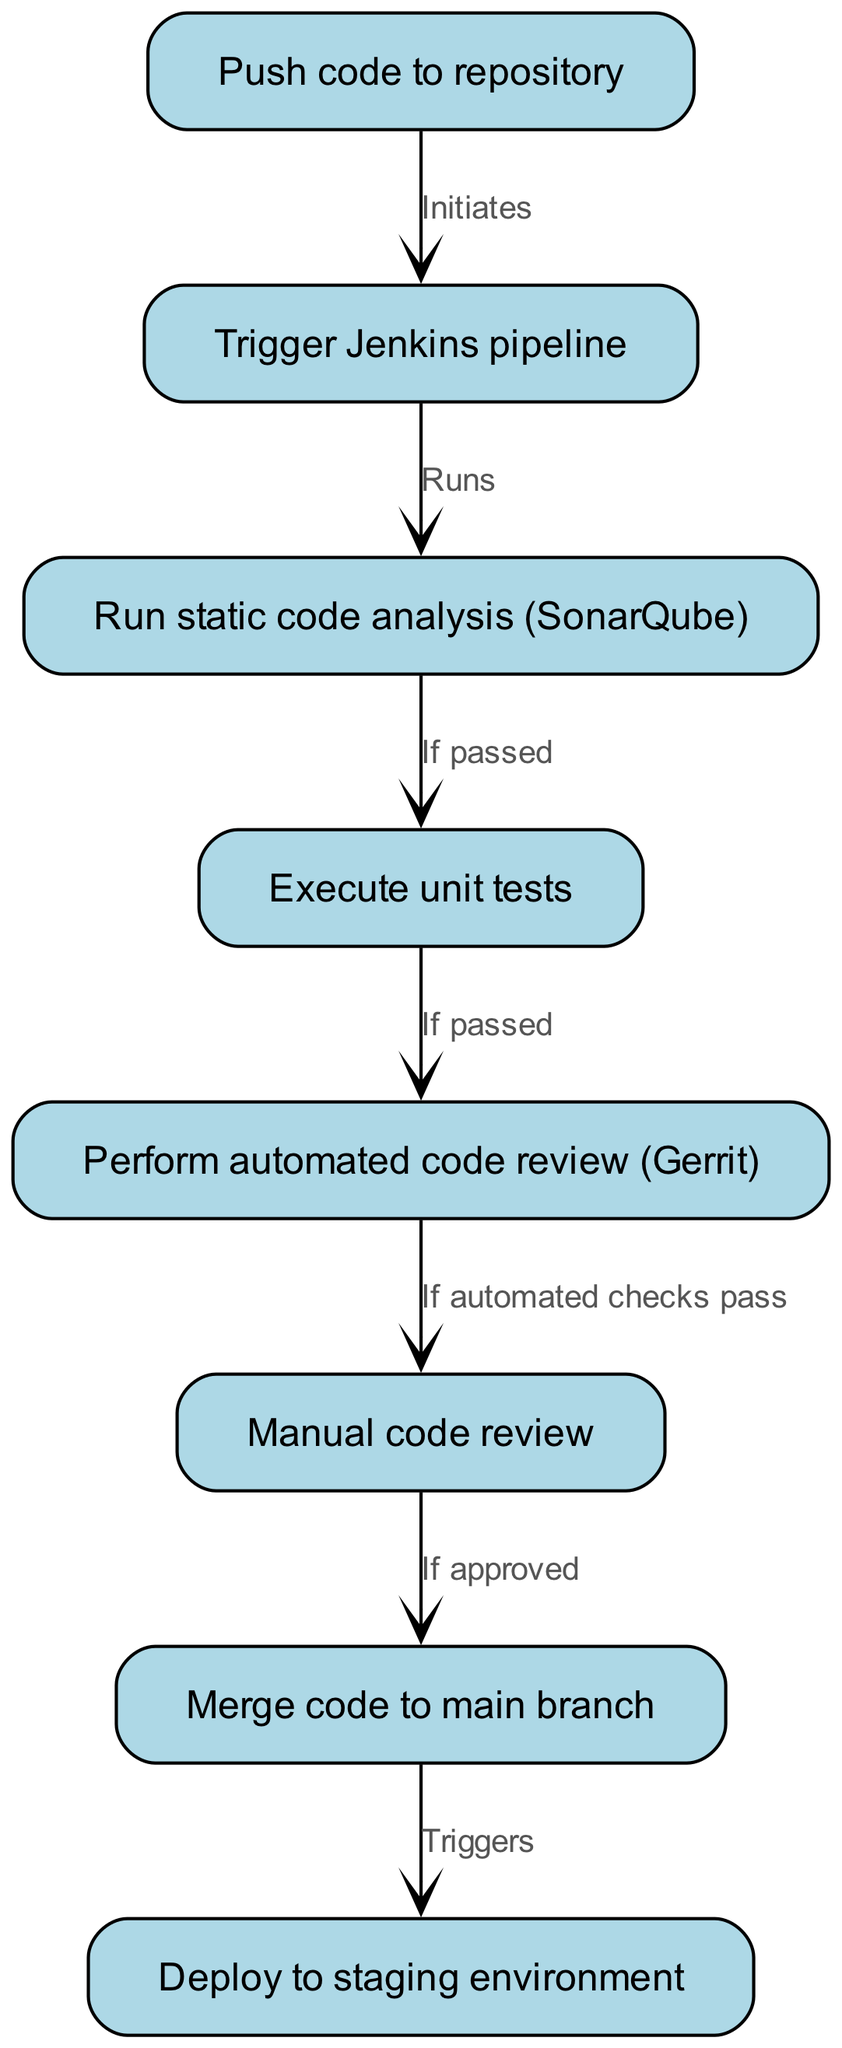What is the first step in the process flow? The first step is labeled as "Push code to repository" as indicated at the beginning of the flowchart. It is the starting point for the automated code review and integration process.
Answer: Push code to repository How many nodes are present in the diagram? The diagram contains eight nodes, each representing a specific step in the automated code review and integration process.
Answer: Eight What action triggers the Jenkins pipeline? The Jenkins pipeline is triggered by the action of pushing code to the repository, represented as the first step in the flow.
Answer: Push code to repository What step follows after the automated code review? The step that follows the automated code review is the manual code review, which occurs if the automated checks pass as indicated in the flow.
Answer: Manual code review What is necessary for the code to be merged into the main branch? The code must be approved during the manual code review step, according to the flowchart, before it can be merged into the main branch.
Answer: If approved What must occur after unit tests for the process to continue? For the process to continue after executing unit tests, those tests must pass; this is specified in the diagram before moving to the next automated code review step.
Answer: If passed How does code reach the staging environment? After the code is merged into the main branch, it triggers the deployment to the staging environment, as indicated by the connection from the merge step to the deployment step.
Answer: Triggers How can the automated code review skip to manual review? The automated code review step proceeds to manual code review only if the automated checks pass, which is specified as a condition in the flow.
Answer: If automated checks pass 